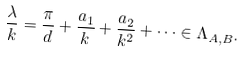<formula> <loc_0><loc_0><loc_500><loc_500>\frac { \lambda } { k } = \frac { \pi } { d } + \frac { a _ { 1 } } { k } + \frac { a _ { 2 } } { k ^ { 2 } } + \dots \in \Lambda _ { A , B } .</formula> 